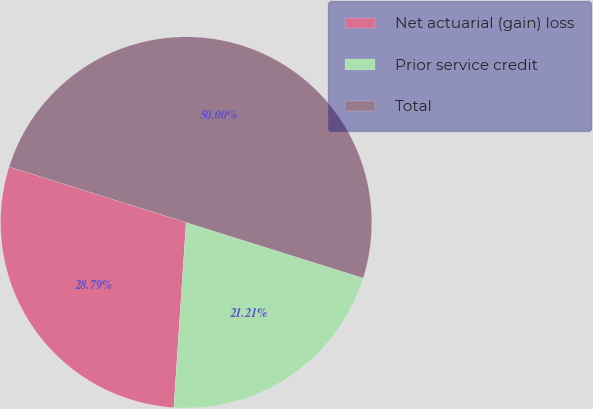Convert chart to OTSL. <chart><loc_0><loc_0><loc_500><loc_500><pie_chart><fcel>Net actuarial (gain) loss<fcel>Prior service credit<fcel>Total<nl><fcel>28.79%<fcel>21.21%<fcel>50.0%<nl></chart> 